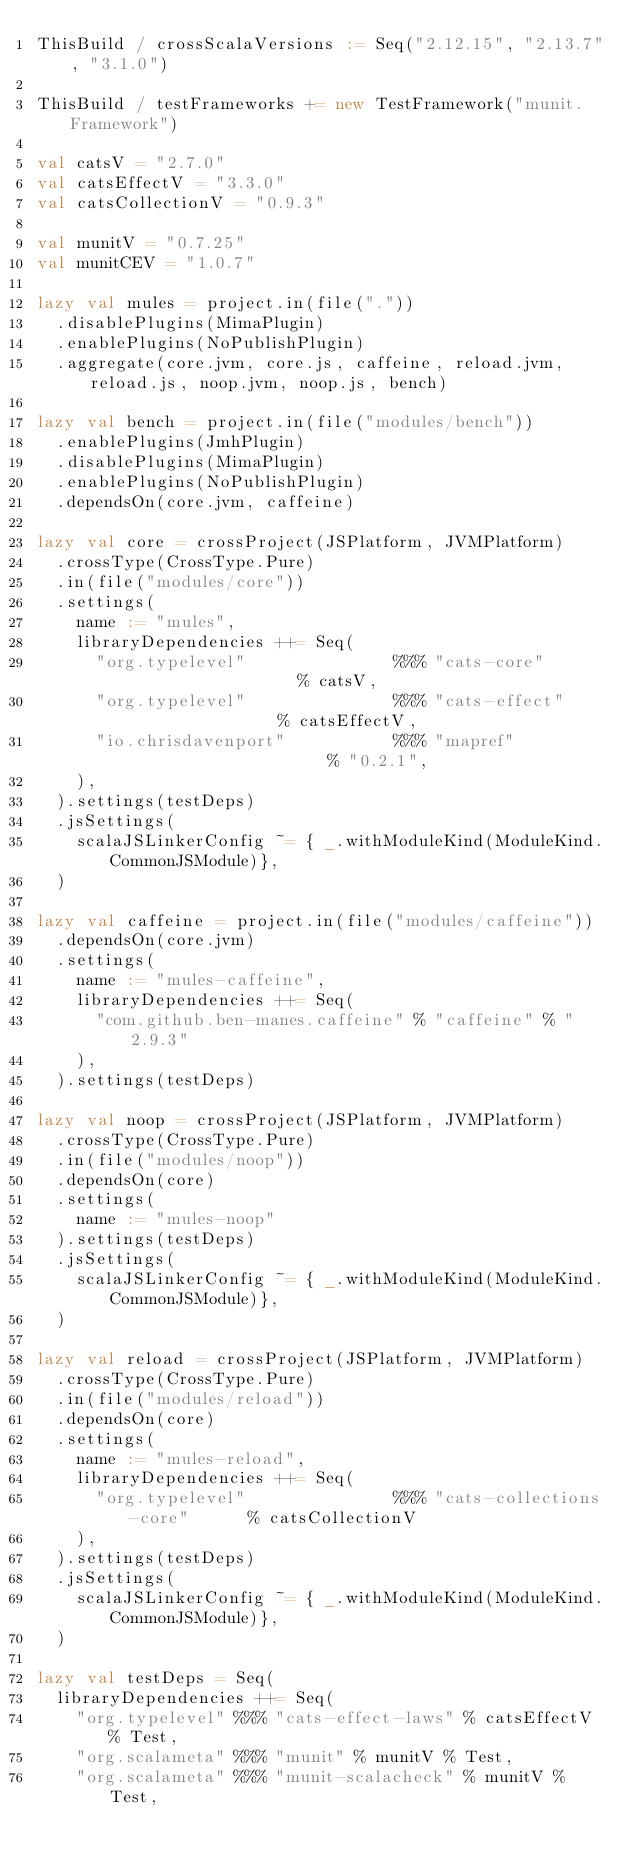<code> <loc_0><loc_0><loc_500><loc_500><_Scala_>ThisBuild / crossScalaVersions := Seq("2.12.15", "2.13.7", "3.1.0")

ThisBuild / testFrameworks += new TestFramework("munit.Framework")

val catsV = "2.7.0"
val catsEffectV = "3.3.0"
val catsCollectionV = "0.9.3"

val munitV = "0.7.25"
val munitCEV = "1.0.7"

lazy val mules = project.in(file("."))
  .disablePlugins(MimaPlugin)
  .enablePlugins(NoPublishPlugin)
  .aggregate(core.jvm, core.js, caffeine, reload.jvm, reload.js, noop.jvm, noop.js, bench)

lazy val bench = project.in(file("modules/bench"))
  .enablePlugins(JmhPlugin)
  .disablePlugins(MimaPlugin)
  .enablePlugins(NoPublishPlugin)
  .dependsOn(core.jvm, caffeine)

lazy val core = crossProject(JSPlatform, JVMPlatform)
  .crossType(CrossType.Pure)
  .in(file("modules/core"))
  .settings(
    name := "mules",
    libraryDependencies ++= Seq(
      "org.typelevel"               %%% "cats-core"                  % catsV,
      "org.typelevel"               %%% "cats-effect"                % catsEffectV,
      "io.chrisdavenport"           %%% "mapref"                     % "0.2.1",
    ),
  ).settings(testDeps)
  .jsSettings(
    scalaJSLinkerConfig ~= { _.withModuleKind(ModuleKind.CommonJSModule)},
  )

lazy val caffeine = project.in(file("modules/caffeine"))
  .dependsOn(core.jvm)
  .settings(
    name := "mules-caffeine",
    libraryDependencies ++= Seq(
      "com.github.ben-manes.caffeine" % "caffeine" % "2.9.3"
    ),
  ).settings(testDeps)

lazy val noop = crossProject(JSPlatform, JVMPlatform)
  .crossType(CrossType.Pure)
  .in(file("modules/noop"))
  .dependsOn(core)
  .settings(
    name := "mules-noop"
  ).settings(testDeps)
  .jsSettings(
    scalaJSLinkerConfig ~= { _.withModuleKind(ModuleKind.CommonJSModule)},
  )

lazy val reload = crossProject(JSPlatform, JVMPlatform)
  .crossType(CrossType.Pure)
  .in(file("modules/reload"))
  .dependsOn(core)
  .settings(
    name := "mules-reload",
    libraryDependencies ++= Seq(
      "org.typelevel"               %%% "cats-collections-core"      % catsCollectionV
    ),
  ).settings(testDeps)
  .jsSettings(
    scalaJSLinkerConfig ~= { _.withModuleKind(ModuleKind.CommonJSModule)},
  )

lazy val testDeps = Seq(
  libraryDependencies ++= Seq(
    "org.typelevel" %%% "cats-effect-laws" % catsEffectV % Test,
    "org.scalameta" %%% "munit" % munitV % Test,
    "org.scalameta" %%% "munit-scalacheck" % munitV % Test,</code> 